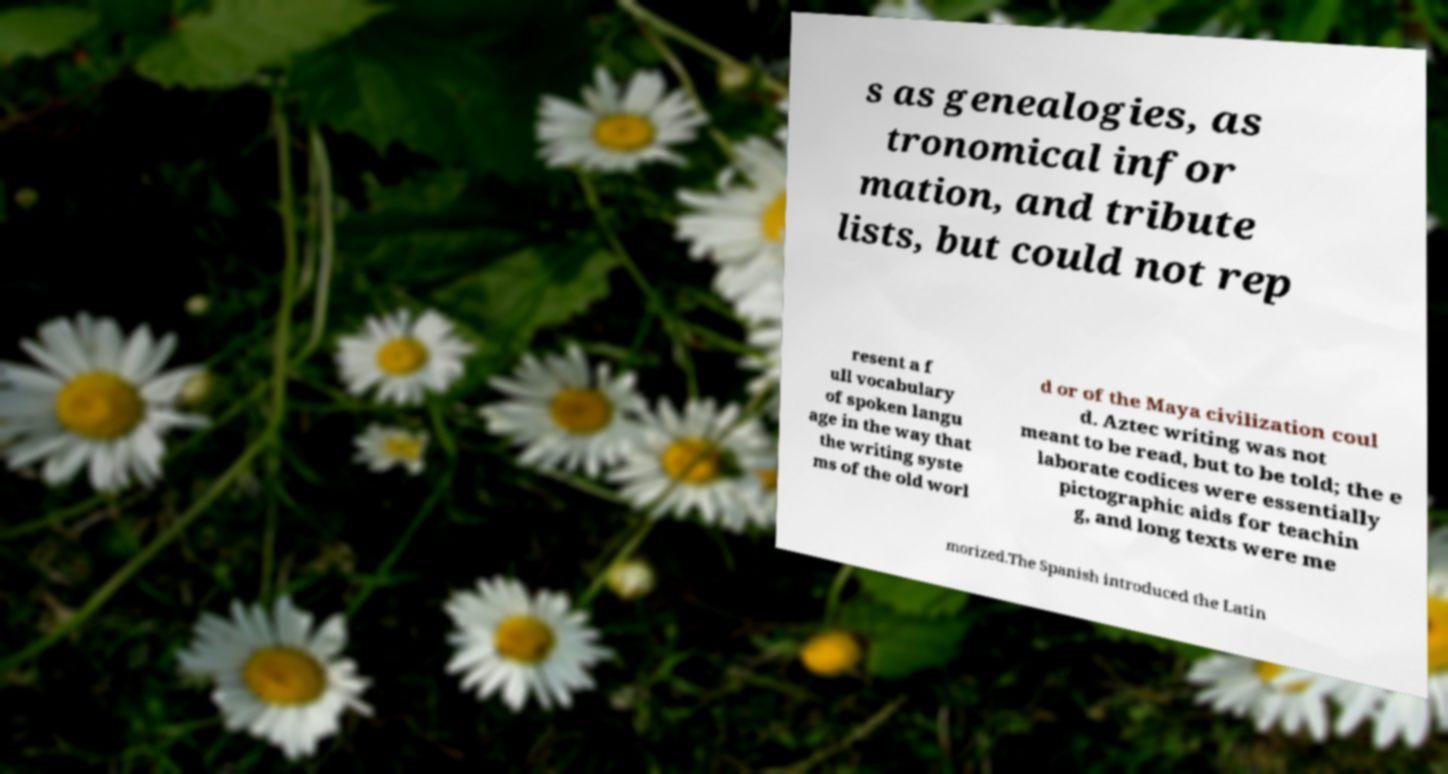For documentation purposes, I need the text within this image transcribed. Could you provide that? s as genealogies, as tronomical infor mation, and tribute lists, but could not rep resent a f ull vocabulary of spoken langu age in the way that the writing syste ms of the old worl d or of the Maya civilization coul d. Aztec writing was not meant to be read, but to be told; the e laborate codices were essentially pictographic aids for teachin g, and long texts were me morized.The Spanish introduced the Latin 